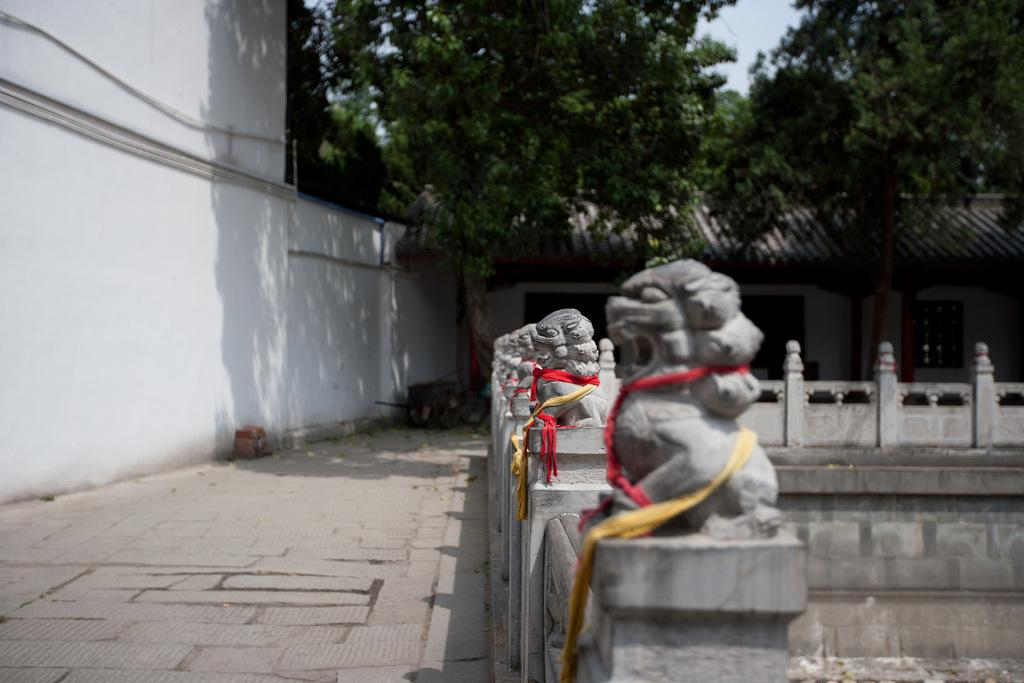What type of objects can be seen in the image? There are statues in the image. What is located to the left of the image? There is a wall to the left of the image. What can be seen in the background of the image? There is a shed and many trees in the background of the image. What part of the natural environment is visible in the image? The sky is visible in the background of the image. What type of cake is being served at the feast in the image? There is no cake or feast present in the image; it features statues, a wall, a shed, trees, and the sky. 